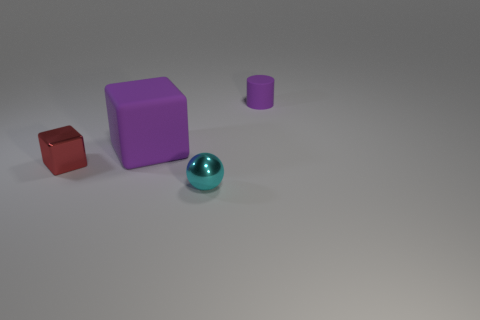There is a cyan sphere in front of the red cube; what is its size?
Keep it short and to the point. Small. How many small things are behind the red cube and to the left of the small cylinder?
Offer a very short reply. 0. The purple object on the left side of the cylinder that is behind the large cube is made of what material?
Provide a short and direct response. Rubber. There is a large purple object that is the same shape as the red object; what material is it?
Offer a very short reply. Rubber. Is there a brown rubber cylinder?
Offer a very short reply. No. What shape is the purple thing that is made of the same material as the small purple cylinder?
Provide a succinct answer. Cube. What is the material of the cylinder to the right of the big cube?
Make the answer very short. Rubber. Does the rubber thing that is to the left of the tiny cyan object have the same color as the cylinder?
Provide a succinct answer. Yes. What is the size of the block that is behind the thing that is left of the large purple matte thing?
Provide a succinct answer. Large. Are there more rubber things to the left of the small ball than small brown cylinders?
Your answer should be compact. Yes. 